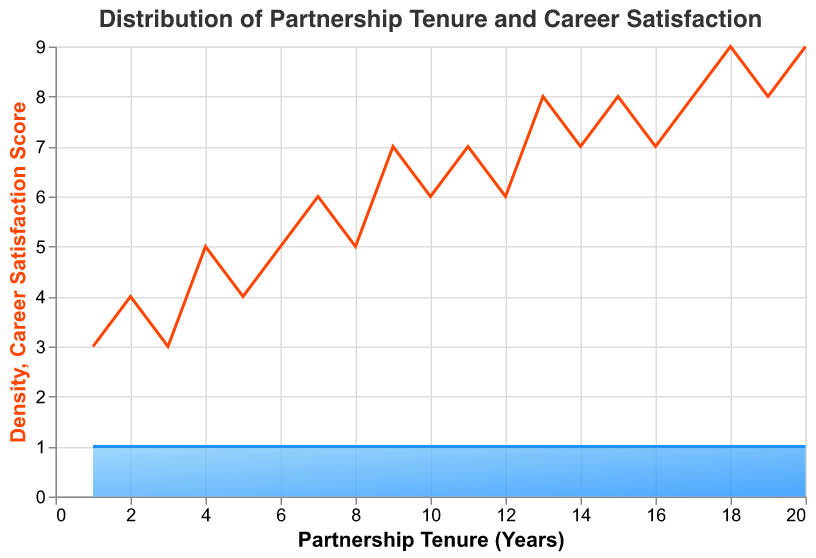what is the title of the plot? The title of the plot is typically located at the top of the figure and provides a general description of what the plot represents. In this case, it describes both the distribution of partnership tenure and its correlation with career satisfaction.
Answer: Distribution of Partnership Tenure and Career Satisfaction What is the color of the area representing the density distribution? The area representing the density distribution is filled with a specific color to distinguish it from other elements in the plot. Here, it transitions from darker to lighter blue.
Answer: Blue What does the y-axis represent in the density plot? The y-axis of the density plot represents the density, which shows how frequently the values occur within the dataset for different partnership tenure years.
Answer: Density What is the range of the partnership tenure represented on the x-axis? The x-axis represents the range of partnership tenure in years, reflecting the span of time partners have been in their roles. In this figure, the range is from 1 to 20 years.
Answer: 1 to 20 years How many data points are used in the plot? By counting the individual data points displayed in the code, one can determine the number of data points used to generate the plot.
Answer: 20 What is the general trend of career satisfaction as partnership tenure increases? Examining the line representing career satisfaction in relation to partnership tenure reveals the trend. Career satisfaction generally tends to increase as partnership tenure increases, indicating a positive correlation.
Answer: Generally increases For which partnership tenure years is career satisfaction the highest? The highest values on the y-axis of the line graph indicate the maximum career satisfaction scores. In this case, career satisfaction scores are highest at 18 and 20 years.
Answer: 18 and 20 years Which partnership tenure years have a career satisfaction score of 7? By identifying the partnership tenure years that correspond to the career satisfaction scores marked as 7 on the plot, we can find these years.
Answer: 9, 11, 14, 16, and 19 years What is career satisfaction score at 5 and 10 Years of tenure? First, locate the points where the partnership tenure years are 5 and 10 on the x-axis and then observe the corresponding y-values which represent career satisfaction scores.
Answer: 4 and 6 respectively What is the difference in career satisfaction scores between partnership tenures of 4 years and 12 years? To find the difference, simply subtract the career satisfaction score at 4 years from the score at 12 years. Here, scores are 5 at 4 years and 6 at 12 years. Thus, 6 - 5 = 1.
Answer: 1 